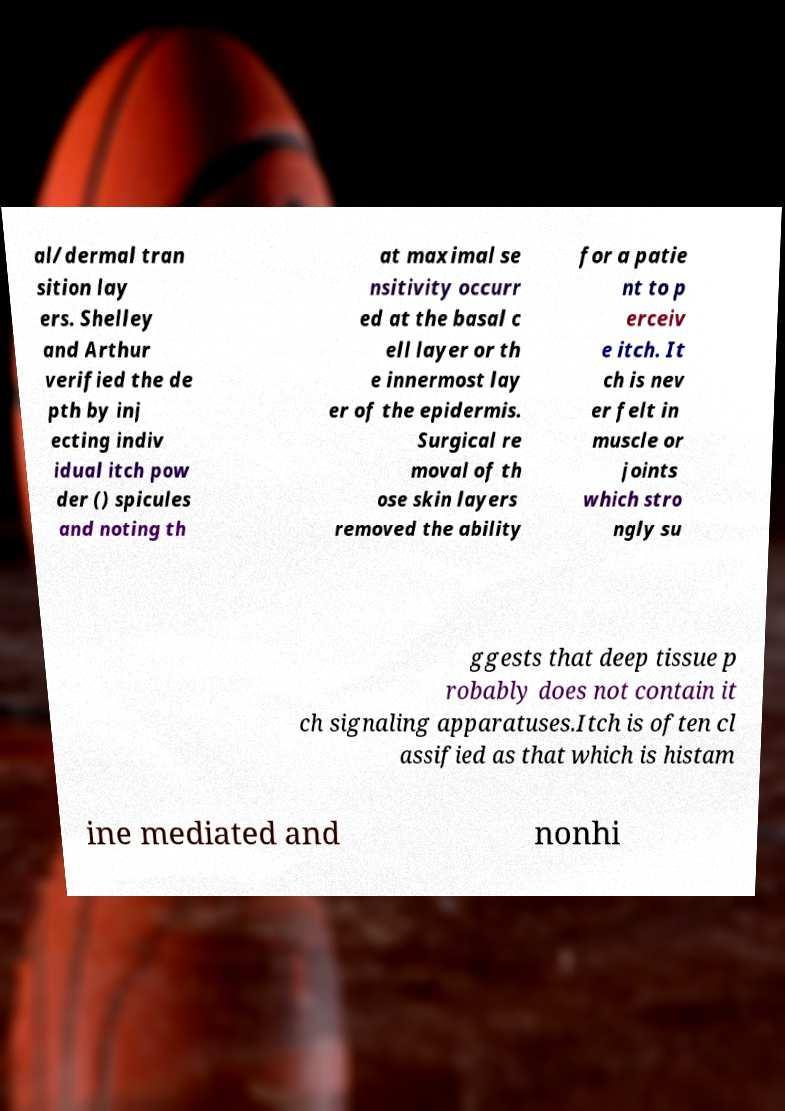Please read and relay the text visible in this image. What does it say? al/dermal tran sition lay ers. Shelley and Arthur verified the de pth by inj ecting indiv idual itch pow der () spicules and noting th at maximal se nsitivity occurr ed at the basal c ell layer or th e innermost lay er of the epidermis. Surgical re moval of th ose skin layers removed the ability for a patie nt to p erceiv e itch. It ch is nev er felt in muscle or joints which stro ngly su ggests that deep tissue p robably does not contain it ch signaling apparatuses.Itch is often cl assified as that which is histam ine mediated and nonhi 